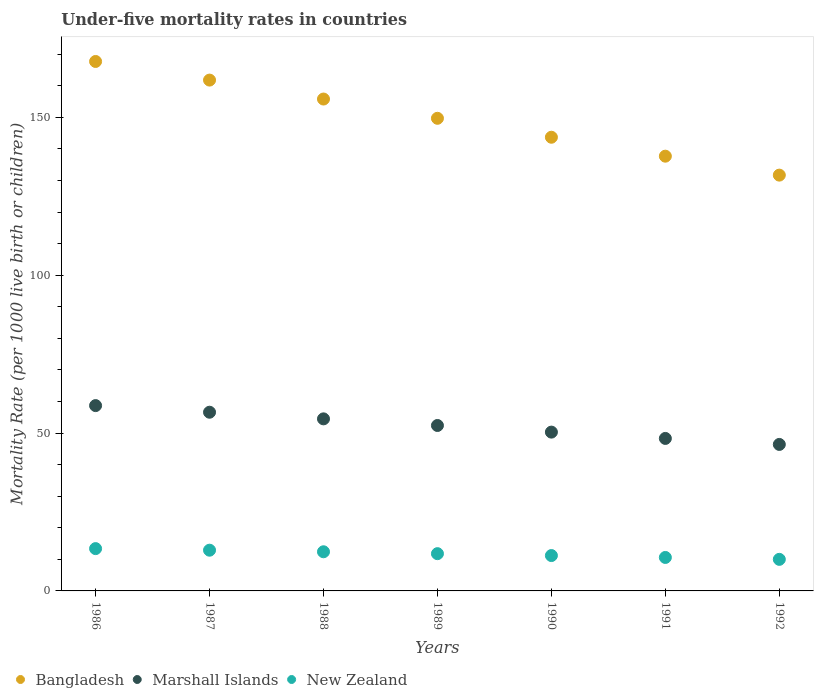How many different coloured dotlines are there?
Provide a succinct answer. 3. What is the under-five mortality rate in Bangladesh in 1992?
Provide a short and direct response. 131.7. Across all years, what is the maximum under-five mortality rate in New Zealand?
Provide a short and direct response. 13.4. Across all years, what is the minimum under-five mortality rate in Marshall Islands?
Offer a very short reply. 46.4. In which year was the under-five mortality rate in Marshall Islands maximum?
Keep it short and to the point. 1986. In which year was the under-five mortality rate in New Zealand minimum?
Your answer should be very brief. 1992. What is the total under-five mortality rate in Marshall Islands in the graph?
Provide a short and direct response. 367.2. What is the difference between the under-five mortality rate in Bangladesh in 1988 and the under-five mortality rate in Marshall Islands in 1987?
Your answer should be very brief. 99.2. What is the average under-five mortality rate in New Zealand per year?
Your answer should be very brief. 11.76. In the year 1992, what is the difference between the under-five mortality rate in New Zealand and under-five mortality rate in Marshall Islands?
Offer a very short reply. -36.4. What is the ratio of the under-five mortality rate in New Zealand in 1986 to that in 1992?
Provide a succinct answer. 1.34. Is the under-five mortality rate in Marshall Islands in 1986 less than that in 1989?
Your response must be concise. No. What is the difference between the highest and the second highest under-five mortality rate in Bangladesh?
Provide a short and direct response. 5.9. What is the difference between the highest and the lowest under-five mortality rate in New Zealand?
Your answer should be very brief. 3.4. Is it the case that in every year, the sum of the under-five mortality rate in Bangladesh and under-five mortality rate in Marshall Islands  is greater than the under-five mortality rate in New Zealand?
Keep it short and to the point. Yes. Is the under-five mortality rate in New Zealand strictly less than the under-five mortality rate in Bangladesh over the years?
Give a very brief answer. Yes. How many dotlines are there?
Provide a short and direct response. 3. What is the difference between two consecutive major ticks on the Y-axis?
Make the answer very short. 50. Does the graph contain any zero values?
Your response must be concise. No. Where does the legend appear in the graph?
Give a very brief answer. Bottom left. How are the legend labels stacked?
Ensure brevity in your answer.  Horizontal. What is the title of the graph?
Offer a terse response. Under-five mortality rates in countries. Does "Guam" appear as one of the legend labels in the graph?
Ensure brevity in your answer.  No. What is the label or title of the X-axis?
Make the answer very short. Years. What is the label or title of the Y-axis?
Make the answer very short. Mortality Rate (per 1000 live birth or children). What is the Mortality Rate (per 1000 live birth or children) in Bangladesh in 1986?
Offer a very short reply. 167.7. What is the Mortality Rate (per 1000 live birth or children) of Marshall Islands in 1986?
Keep it short and to the point. 58.7. What is the Mortality Rate (per 1000 live birth or children) in Bangladesh in 1987?
Provide a short and direct response. 161.8. What is the Mortality Rate (per 1000 live birth or children) in Marshall Islands in 1987?
Offer a terse response. 56.6. What is the Mortality Rate (per 1000 live birth or children) in Bangladesh in 1988?
Keep it short and to the point. 155.8. What is the Mortality Rate (per 1000 live birth or children) in Marshall Islands in 1988?
Offer a very short reply. 54.5. What is the Mortality Rate (per 1000 live birth or children) in New Zealand in 1988?
Make the answer very short. 12.4. What is the Mortality Rate (per 1000 live birth or children) of Bangladesh in 1989?
Your response must be concise. 149.7. What is the Mortality Rate (per 1000 live birth or children) in Marshall Islands in 1989?
Provide a succinct answer. 52.4. What is the Mortality Rate (per 1000 live birth or children) of New Zealand in 1989?
Your answer should be very brief. 11.8. What is the Mortality Rate (per 1000 live birth or children) of Bangladesh in 1990?
Give a very brief answer. 143.7. What is the Mortality Rate (per 1000 live birth or children) in Marshall Islands in 1990?
Provide a short and direct response. 50.3. What is the Mortality Rate (per 1000 live birth or children) in Bangladesh in 1991?
Your response must be concise. 137.7. What is the Mortality Rate (per 1000 live birth or children) in Marshall Islands in 1991?
Provide a short and direct response. 48.3. What is the Mortality Rate (per 1000 live birth or children) of Bangladesh in 1992?
Offer a very short reply. 131.7. What is the Mortality Rate (per 1000 live birth or children) in Marshall Islands in 1992?
Make the answer very short. 46.4. Across all years, what is the maximum Mortality Rate (per 1000 live birth or children) of Bangladesh?
Offer a terse response. 167.7. Across all years, what is the maximum Mortality Rate (per 1000 live birth or children) of Marshall Islands?
Your answer should be very brief. 58.7. Across all years, what is the maximum Mortality Rate (per 1000 live birth or children) of New Zealand?
Your answer should be compact. 13.4. Across all years, what is the minimum Mortality Rate (per 1000 live birth or children) of Bangladesh?
Make the answer very short. 131.7. Across all years, what is the minimum Mortality Rate (per 1000 live birth or children) of Marshall Islands?
Make the answer very short. 46.4. What is the total Mortality Rate (per 1000 live birth or children) in Bangladesh in the graph?
Offer a terse response. 1048.1. What is the total Mortality Rate (per 1000 live birth or children) in Marshall Islands in the graph?
Provide a short and direct response. 367.2. What is the total Mortality Rate (per 1000 live birth or children) in New Zealand in the graph?
Provide a succinct answer. 82.3. What is the difference between the Mortality Rate (per 1000 live birth or children) of Bangladesh in 1986 and that in 1987?
Your answer should be compact. 5.9. What is the difference between the Mortality Rate (per 1000 live birth or children) in New Zealand in 1986 and that in 1987?
Your answer should be very brief. 0.5. What is the difference between the Mortality Rate (per 1000 live birth or children) in Bangladesh in 1986 and that in 1988?
Give a very brief answer. 11.9. What is the difference between the Mortality Rate (per 1000 live birth or children) of New Zealand in 1986 and that in 1988?
Your answer should be compact. 1. What is the difference between the Mortality Rate (per 1000 live birth or children) of Marshall Islands in 1986 and that in 1990?
Give a very brief answer. 8.4. What is the difference between the Mortality Rate (per 1000 live birth or children) of New Zealand in 1986 and that in 1991?
Give a very brief answer. 2.8. What is the difference between the Mortality Rate (per 1000 live birth or children) in Marshall Islands in 1987 and that in 1988?
Your response must be concise. 2.1. What is the difference between the Mortality Rate (per 1000 live birth or children) of New Zealand in 1987 and that in 1988?
Keep it short and to the point. 0.5. What is the difference between the Mortality Rate (per 1000 live birth or children) in Marshall Islands in 1987 and that in 1989?
Provide a succinct answer. 4.2. What is the difference between the Mortality Rate (per 1000 live birth or children) of New Zealand in 1987 and that in 1990?
Give a very brief answer. 1.7. What is the difference between the Mortality Rate (per 1000 live birth or children) in Bangladesh in 1987 and that in 1991?
Provide a short and direct response. 24.1. What is the difference between the Mortality Rate (per 1000 live birth or children) of Marshall Islands in 1987 and that in 1991?
Make the answer very short. 8.3. What is the difference between the Mortality Rate (per 1000 live birth or children) of New Zealand in 1987 and that in 1991?
Provide a succinct answer. 2.3. What is the difference between the Mortality Rate (per 1000 live birth or children) of Bangladesh in 1987 and that in 1992?
Provide a succinct answer. 30.1. What is the difference between the Mortality Rate (per 1000 live birth or children) in Marshall Islands in 1987 and that in 1992?
Your response must be concise. 10.2. What is the difference between the Mortality Rate (per 1000 live birth or children) in Bangladesh in 1988 and that in 1989?
Your response must be concise. 6.1. What is the difference between the Mortality Rate (per 1000 live birth or children) in Bangladesh in 1988 and that in 1991?
Provide a succinct answer. 18.1. What is the difference between the Mortality Rate (per 1000 live birth or children) in Bangladesh in 1988 and that in 1992?
Keep it short and to the point. 24.1. What is the difference between the Mortality Rate (per 1000 live birth or children) of Marshall Islands in 1988 and that in 1992?
Your answer should be very brief. 8.1. What is the difference between the Mortality Rate (per 1000 live birth or children) of Bangladesh in 1989 and that in 1990?
Offer a very short reply. 6. What is the difference between the Mortality Rate (per 1000 live birth or children) of Marshall Islands in 1989 and that in 1990?
Your answer should be compact. 2.1. What is the difference between the Mortality Rate (per 1000 live birth or children) in Marshall Islands in 1989 and that in 1991?
Provide a short and direct response. 4.1. What is the difference between the Mortality Rate (per 1000 live birth or children) in New Zealand in 1989 and that in 1991?
Make the answer very short. 1.2. What is the difference between the Mortality Rate (per 1000 live birth or children) in Marshall Islands in 1989 and that in 1992?
Your response must be concise. 6. What is the difference between the Mortality Rate (per 1000 live birth or children) of New Zealand in 1990 and that in 1991?
Offer a terse response. 0.6. What is the difference between the Mortality Rate (per 1000 live birth or children) in New Zealand in 1991 and that in 1992?
Ensure brevity in your answer.  0.6. What is the difference between the Mortality Rate (per 1000 live birth or children) in Bangladesh in 1986 and the Mortality Rate (per 1000 live birth or children) in Marshall Islands in 1987?
Offer a very short reply. 111.1. What is the difference between the Mortality Rate (per 1000 live birth or children) in Bangladesh in 1986 and the Mortality Rate (per 1000 live birth or children) in New Zealand in 1987?
Provide a short and direct response. 154.8. What is the difference between the Mortality Rate (per 1000 live birth or children) in Marshall Islands in 1986 and the Mortality Rate (per 1000 live birth or children) in New Zealand in 1987?
Your answer should be compact. 45.8. What is the difference between the Mortality Rate (per 1000 live birth or children) in Bangladesh in 1986 and the Mortality Rate (per 1000 live birth or children) in Marshall Islands in 1988?
Offer a very short reply. 113.2. What is the difference between the Mortality Rate (per 1000 live birth or children) in Bangladesh in 1986 and the Mortality Rate (per 1000 live birth or children) in New Zealand in 1988?
Provide a succinct answer. 155.3. What is the difference between the Mortality Rate (per 1000 live birth or children) in Marshall Islands in 1986 and the Mortality Rate (per 1000 live birth or children) in New Zealand in 1988?
Your answer should be very brief. 46.3. What is the difference between the Mortality Rate (per 1000 live birth or children) of Bangladesh in 1986 and the Mortality Rate (per 1000 live birth or children) of Marshall Islands in 1989?
Your response must be concise. 115.3. What is the difference between the Mortality Rate (per 1000 live birth or children) in Bangladesh in 1986 and the Mortality Rate (per 1000 live birth or children) in New Zealand in 1989?
Provide a short and direct response. 155.9. What is the difference between the Mortality Rate (per 1000 live birth or children) in Marshall Islands in 1986 and the Mortality Rate (per 1000 live birth or children) in New Zealand in 1989?
Keep it short and to the point. 46.9. What is the difference between the Mortality Rate (per 1000 live birth or children) in Bangladesh in 1986 and the Mortality Rate (per 1000 live birth or children) in Marshall Islands in 1990?
Give a very brief answer. 117.4. What is the difference between the Mortality Rate (per 1000 live birth or children) in Bangladesh in 1986 and the Mortality Rate (per 1000 live birth or children) in New Zealand in 1990?
Provide a succinct answer. 156.5. What is the difference between the Mortality Rate (per 1000 live birth or children) in Marshall Islands in 1986 and the Mortality Rate (per 1000 live birth or children) in New Zealand in 1990?
Make the answer very short. 47.5. What is the difference between the Mortality Rate (per 1000 live birth or children) in Bangladesh in 1986 and the Mortality Rate (per 1000 live birth or children) in Marshall Islands in 1991?
Keep it short and to the point. 119.4. What is the difference between the Mortality Rate (per 1000 live birth or children) in Bangladesh in 1986 and the Mortality Rate (per 1000 live birth or children) in New Zealand in 1991?
Your answer should be compact. 157.1. What is the difference between the Mortality Rate (per 1000 live birth or children) in Marshall Islands in 1986 and the Mortality Rate (per 1000 live birth or children) in New Zealand in 1991?
Your response must be concise. 48.1. What is the difference between the Mortality Rate (per 1000 live birth or children) of Bangladesh in 1986 and the Mortality Rate (per 1000 live birth or children) of Marshall Islands in 1992?
Provide a short and direct response. 121.3. What is the difference between the Mortality Rate (per 1000 live birth or children) of Bangladesh in 1986 and the Mortality Rate (per 1000 live birth or children) of New Zealand in 1992?
Your answer should be very brief. 157.7. What is the difference between the Mortality Rate (per 1000 live birth or children) in Marshall Islands in 1986 and the Mortality Rate (per 1000 live birth or children) in New Zealand in 1992?
Provide a short and direct response. 48.7. What is the difference between the Mortality Rate (per 1000 live birth or children) in Bangladesh in 1987 and the Mortality Rate (per 1000 live birth or children) in Marshall Islands in 1988?
Give a very brief answer. 107.3. What is the difference between the Mortality Rate (per 1000 live birth or children) in Bangladesh in 1987 and the Mortality Rate (per 1000 live birth or children) in New Zealand in 1988?
Make the answer very short. 149.4. What is the difference between the Mortality Rate (per 1000 live birth or children) in Marshall Islands in 1987 and the Mortality Rate (per 1000 live birth or children) in New Zealand in 1988?
Offer a terse response. 44.2. What is the difference between the Mortality Rate (per 1000 live birth or children) in Bangladesh in 1987 and the Mortality Rate (per 1000 live birth or children) in Marshall Islands in 1989?
Ensure brevity in your answer.  109.4. What is the difference between the Mortality Rate (per 1000 live birth or children) of Bangladesh in 1987 and the Mortality Rate (per 1000 live birth or children) of New Zealand in 1989?
Your response must be concise. 150. What is the difference between the Mortality Rate (per 1000 live birth or children) in Marshall Islands in 1987 and the Mortality Rate (per 1000 live birth or children) in New Zealand in 1989?
Your answer should be compact. 44.8. What is the difference between the Mortality Rate (per 1000 live birth or children) of Bangladesh in 1987 and the Mortality Rate (per 1000 live birth or children) of Marshall Islands in 1990?
Provide a succinct answer. 111.5. What is the difference between the Mortality Rate (per 1000 live birth or children) in Bangladesh in 1987 and the Mortality Rate (per 1000 live birth or children) in New Zealand in 1990?
Make the answer very short. 150.6. What is the difference between the Mortality Rate (per 1000 live birth or children) of Marshall Islands in 1987 and the Mortality Rate (per 1000 live birth or children) of New Zealand in 1990?
Ensure brevity in your answer.  45.4. What is the difference between the Mortality Rate (per 1000 live birth or children) in Bangladesh in 1987 and the Mortality Rate (per 1000 live birth or children) in Marshall Islands in 1991?
Keep it short and to the point. 113.5. What is the difference between the Mortality Rate (per 1000 live birth or children) in Bangladesh in 1987 and the Mortality Rate (per 1000 live birth or children) in New Zealand in 1991?
Your response must be concise. 151.2. What is the difference between the Mortality Rate (per 1000 live birth or children) of Bangladesh in 1987 and the Mortality Rate (per 1000 live birth or children) of Marshall Islands in 1992?
Provide a succinct answer. 115.4. What is the difference between the Mortality Rate (per 1000 live birth or children) of Bangladesh in 1987 and the Mortality Rate (per 1000 live birth or children) of New Zealand in 1992?
Your answer should be very brief. 151.8. What is the difference between the Mortality Rate (per 1000 live birth or children) in Marshall Islands in 1987 and the Mortality Rate (per 1000 live birth or children) in New Zealand in 1992?
Offer a very short reply. 46.6. What is the difference between the Mortality Rate (per 1000 live birth or children) in Bangladesh in 1988 and the Mortality Rate (per 1000 live birth or children) in Marshall Islands in 1989?
Provide a short and direct response. 103.4. What is the difference between the Mortality Rate (per 1000 live birth or children) of Bangladesh in 1988 and the Mortality Rate (per 1000 live birth or children) of New Zealand in 1989?
Your answer should be compact. 144. What is the difference between the Mortality Rate (per 1000 live birth or children) in Marshall Islands in 1988 and the Mortality Rate (per 1000 live birth or children) in New Zealand in 1989?
Offer a terse response. 42.7. What is the difference between the Mortality Rate (per 1000 live birth or children) in Bangladesh in 1988 and the Mortality Rate (per 1000 live birth or children) in Marshall Islands in 1990?
Your answer should be very brief. 105.5. What is the difference between the Mortality Rate (per 1000 live birth or children) in Bangladesh in 1988 and the Mortality Rate (per 1000 live birth or children) in New Zealand in 1990?
Offer a terse response. 144.6. What is the difference between the Mortality Rate (per 1000 live birth or children) of Marshall Islands in 1988 and the Mortality Rate (per 1000 live birth or children) of New Zealand in 1990?
Give a very brief answer. 43.3. What is the difference between the Mortality Rate (per 1000 live birth or children) in Bangladesh in 1988 and the Mortality Rate (per 1000 live birth or children) in Marshall Islands in 1991?
Give a very brief answer. 107.5. What is the difference between the Mortality Rate (per 1000 live birth or children) of Bangladesh in 1988 and the Mortality Rate (per 1000 live birth or children) of New Zealand in 1991?
Provide a short and direct response. 145.2. What is the difference between the Mortality Rate (per 1000 live birth or children) of Marshall Islands in 1988 and the Mortality Rate (per 1000 live birth or children) of New Zealand in 1991?
Offer a terse response. 43.9. What is the difference between the Mortality Rate (per 1000 live birth or children) of Bangladesh in 1988 and the Mortality Rate (per 1000 live birth or children) of Marshall Islands in 1992?
Your answer should be very brief. 109.4. What is the difference between the Mortality Rate (per 1000 live birth or children) of Bangladesh in 1988 and the Mortality Rate (per 1000 live birth or children) of New Zealand in 1992?
Your response must be concise. 145.8. What is the difference between the Mortality Rate (per 1000 live birth or children) of Marshall Islands in 1988 and the Mortality Rate (per 1000 live birth or children) of New Zealand in 1992?
Your answer should be compact. 44.5. What is the difference between the Mortality Rate (per 1000 live birth or children) of Bangladesh in 1989 and the Mortality Rate (per 1000 live birth or children) of Marshall Islands in 1990?
Provide a succinct answer. 99.4. What is the difference between the Mortality Rate (per 1000 live birth or children) of Bangladesh in 1989 and the Mortality Rate (per 1000 live birth or children) of New Zealand in 1990?
Keep it short and to the point. 138.5. What is the difference between the Mortality Rate (per 1000 live birth or children) of Marshall Islands in 1989 and the Mortality Rate (per 1000 live birth or children) of New Zealand in 1990?
Keep it short and to the point. 41.2. What is the difference between the Mortality Rate (per 1000 live birth or children) of Bangladesh in 1989 and the Mortality Rate (per 1000 live birth or children) of Marshall Islands in 1991?
Provide a short and direct response. 101.4. What is the difference between the Mortality Rate (per 1000 live birth or children) in Bangladesh in 1989 and the Mortality Rate (per 1000 live birth or children) in New Zealand in 1991?
Offer a terse response. 139.1. What is the difference between the Mortality Rate (per 1000 live birth or children) of Marshall Islands in 1989 and the Mortality Rate (per 1000 live birth or children) of New Zealand in 1991?
Ensure brevity in your answer.  41.8. What is the difference between the Mortality Rate (per 1000 live birth or children) in Bangladesh in 1989 and the Mortality Rate (per 1000 live birth or children) in Marshall Islands in 1992?
Your answer should be very brief. 103.3. What is the difference between the Mortality Rate (per 1000 live birth or children) in Bangladesh in 1989 and the Mortality Rate (per 1000 live birth or children) in New Zealand in 1992?
Your answer should be very brief. 139.7. What is the difference between the Mortality Rate (per 1000 live birth or children) in Marshall Islands in 1989 and the Mortality Rate (per 1000 live birth or children) in New Zealand in 1992?
Keep it short and to the point. 42.4. What is the difference between the Mortality Rate (per 1000 live birth or children) in Bangladesh in 1990 and the Mortality Rate (per 1000 live birth or children) in Marshall Islands in 1991?
Your answer should be compact. 95.4. What is the difference between the Mortality Rate (per 1000 live birth or children) in Bangladesh in 1990 and the Mortality Rate (per 1000 live birth or children) in New Zealand in 1991?
Your answer should be compact. 133.1. What is the difference between the Mortality Rate (per 1000 live birth or children) in Marshall Islands in 1990 and the Mortality Rate (per 1000 live birth or children) in New Zealand in 1991?
Your answer should be compact. 39.7. What is the difference between the Mortality Rate (per 1000 live birth or children) of Bangladesh in 1990 and the Mortality Rate (per 1000 live birth or children) of Marshall Islands in 1992?
Ensure brevity in your answer.  97.3. What is the difference between the Mortality Rate (per 1000 live birth or children) of Bangladesh in 1990 and the Mortality Rate (per 1000 live birth or children) of New Zealand in 1992?
Offer a terse response. 133.7. What is the difference between the Mortality Rate (per 1000 live birth or children) of Marshall Islands in 1990 and the Mortality Rate (per 1000 live birth or children) of New Zealand in 1992?
Provide a short and direct response. 40.3. What is the difference between the Mortality Rate (per 1000 live birth or children) of Bangladesh in 1991 and the Mortality Rate (per 1000 live birth or children) of Marshall Islands in 1992?
Provide a short and direct response. 91.3. What is the difference between the Mortality Rate (per 1000 live birth or children) of Bangladesh in 1991 and the Mortality Rate (per 1000 live birth or children) of New Zealand in 1992?
Provide a succinct answer. 127.7. What is the difference between the Mortality Rate (per 1000 live birth or children) of Marshall Islands in 1991 and the Mortality Rate (per 1000 live birth or children) of New Zealand in 1992?
Give a very brief answer. 38.3. What is the average Mortality Rate (per 1000 live birth or children) in Bangladesh per year?
Make the answer very short. 149.73. What is the average Mortality Rate (per 1000 live birth or children) of Marshall Islands per year?
Your response must be concise. 52.46. What is the average Mortality Rate (per 1000 live birth or children) in New Zealand per year?
Your answer should be compact. 11.76. In the year 1986, what is the difference between the Mortality Rate (per 1000 live birth or children) in Bangladesh and Mortality Rate (per 1000 live birth or children) in Marshall Islands?
Keep it short and to the point. 109. In the year 1986, what is the difference between the Mortality Rate (per 1000 live birth or children) in Bangladesh and Mortality Rate (per 1000 live birth or children) in New Zealand?
Your response must be concise. 154.3. In the year 1986, what is the difference between the Mortality Rate (per 1000 live birth or children) of Marshall Islands and Mortality Rate (per 1000 live birth or children) of New Zealand?
Offer a very short reply. 45.3. In the year 1987, what is the difference between the Mortality Rate (per 1000 live birth or children) in Bangladesh and Mortality Rate (per 1000 live birth or children) in Marshall Islands?
Provide a short and direct response. 105.2. In the year 1987, what is the difference between the Mortality Rate (per 1000 live birth or children) in Bangladesh and Mortality Rate (per 1000 live birth or children) in New Zealand?
Your response must be concise. 148.9. In the year 1987, what is the difference between the Mortality Rate (per 1000 live birth or children) of Marshall Islands and Mortality Rate (per 1000 live birth or children) of New Zealand?
Ensure brevity in your answer.  43.7. In the year 1988, what is the difference between the Mortality Rate (per 1000 live birth or children) of Bangladesh and Mortality Rate (per 1000 live birth or children) of Marshall Islands?
Your response must be concise. 101.3. In the year 1988, what is the difference between the Mortality Rate (per 1000 live birth or children) of Bangladesh and Mortality Rate (per 1000 live birth or children) of New Zealand?
Keep it short and to the point. 143.4. In the year 1988, what is the difference between the Mortality Rate (per 1000 live birth or children) of Marshall Islands and Mortality Rate (per 1000 live birth or children) of New Zealand?
Make the answer very short. 42.1. In the year 1989, what is the difference between the Mortality Rate (per 1000 live birth or children) in Bangladesh and Mortality Rate (per 1000 live birth or children) in Marshall Islands?
Make the answer very short. 97.3. In the year 1989, what is the difference between the Mortality Rate (per 1000 live birth or children) in Bangladesh and Mortality Rate (per 1000 live birth or children) in New Zealand?
Your answer should be very brief. 137.9. In the year 1989, what is the difference between the Mortality Rate (per 1000 live birth or children) of Marshall Islands and Mortality Rate (per 1000 live birth or children) of New Zealand?
Provide a succinct answer. 40.6. In the year 1990, what is the difference between the Mortality Rate (per 1000 live birth or children) of Bangladesh and Mortality Rate (per 1000 live birth or children) of Marshall Islands?
Keep it short and to the point. 93.4. In the year 1990, what is the difference between the Mortality Rate (per 1000 live birth or children) in Bangladesh and Mortality Rate (per 1000 live birth or children) in New Zealand?
Your response must be concise. 132.5. In the year 1990, what is the difference between the Mortality Rate (per 1000 live birth or children) in Marshall Islands and Mortality Rate (per 1000 live birth or children) in New Zealand?
Give a very brief answer. 39.1. In the year 1991, what is the difference between the Mortality Rate (per 1000 live birth or children) in Bangladesh and Mortality Rate (per 1000 live birth or children) in Marshall Islands?
Offer a terse response. 89.4. In the year 1991, what is the difference between the Mortality Rate (per 1000 live birth or children) of Bangladesh and Mortality Rate (per 1000 live birth or children) of New Zealand?
Ensure brevity in your answer.  127.1. In the year 1991, what is the difference between the Mortality Rate (per 1000 live birth or children) in Marshall Islands and Mortality Rate (per 1000 live birth or children) in New Zealand?
Your response must be concise. 37.7. In the year 1992, what is the difference between the Mortality Rate (per 1000 live birth or children) of Bangladesh and Mortality Rate (per 1000 live birth or children) of Marshall Islands?
Provide a succinct answer. 85.3. In the year 1992, what is the difference between the Mortality Rate (per 1000 live birth or children) of Bangladesh and Mortality Rate (per 1000 live birth or children) of New Zealand?
Provide a succinct answer. 121.7. In the year 1992, what is the difference between the Mortality Rate (per 1000 live birth or children) of Marshall Islands and Mortality Rate (per 1000 live birth or children) of New Zealand?
Make the answer very short. 36.4. What is the ratio of the Mortality Rate (per 1000 live birth or children) of Bangladesh in 1986 to that in 1987?
Keep it short and to the point. 1.04. What is the ratio of the Mortality Rate (per 1000 live birth or children) of Marshall Islands in 1986 to that in 1987?
Offer a very short reply. 1.04. What is the ratio of the Mortality Rate (per 1000 live birth or children) in New Zealand in 1986 to that in 1987?
Offer a terse response. 1.04. What is the ratio of the Mortality Rate (per 1000 live birth or children) in Bangladesh in 1986 to that in 1988?
Your response must be concise. 1.08. What is the ratio of the Mortality Rate (per 1000 live birth or children) of Marshall Islands in 1986 to that in 1988?
Offer a very short reply. 1.08. What is the ratio of the Mortality Rate (per 1000 live birth or children) in New Zealand in 1986 to that in 1988?
Offer a very short reply. 1.08. What is the ratio of the Mortality Rate (per 1000 live birth or children) of Bangladesh in 1986 to that in 1989?
Your answer should be compact. 1.12. What is the ratio of the Mortality Rate (per 1000 live birth or children) of Marshall Islands in 1986 to that in 1989?
Provide a succinct answer. 1.12. What is the ratio of the Mortality Rate (per 1000 live birth or children) of New Zealand in 1986 to that in 1989?
Your answer should be very brief. 1.14. What is the ratio of the Mortality Rate (per 1000 live birth or children) of Bangladesh in 1986 to that in 1990?
Provide a short and direct response. 1.17. What is the ratio of the Mortality Rate (per 1000 live birth or children) of Marshall Islands in 1986 to that in 1990?
Ensure brevity in your answer.  1.17. What is the ratio of the Mortality Rate (per 1000 live birth or children) in New Zealand in 1986 to that in 1990?
Offer a terse response. 1.2. What is the ratio of the Mortality Rate (per 1000 live birth or children) in Bangladesh in 1986 to that in 1991?
Give a very brief answer. 1.22. What is the ratio of the Mortality Rate (per 1000 live birth or children) in Marshall Islands in 1986 to that in 1991?
Your answer should be compact. 1.22. What is the ratio of the Mortality Rate (per 1000 live birth or children) in New Zealand in 1986 to that in 1991?
Provide a short and direct response. 1.26. What is the ratio of the Mortality Rate (per 1000 live birth or children) of Bangladesh in 1986 to that in 1992?
Give a very brief answer. 1.27. What is the ratio of the Mortality Rate (per 1000 live birth or children) of Marshall Islands in 1986 to that in 1992?
Offer a very short reply. 1.27. What is the ratio of the Mortality Rate (per 1000 live birth or children) of New Zealand in 1986 to that in 1992?
Your answer should be compact. 1.34. What is the ratio of the Mortality Rate (per 1000 live birth or children) in Bangladesh in 1987 to that in 1988?
Keep it short and to the point. 1.04. What is the ratio of the Mortality Rate (per 1000 live birth or children) of New Zealand in 1987 to that in 1988?
Your answer should be compact. 1.04. What is the ratio of the Mortality Rate (per 1000 live birth or children) of Bangladesh in 1987 to that in 1989?
Provide a short and direct response. 1.08. What is the ratio of the Mortality Rate (per 1000 live birth or children) of Marshall Islands in 1987 to that in 1989?
Provide a succinct answer. 1.08. What is the ratio of the Mortality Rate (per 1000 live birth or children) in New Zealand in 1987 to that in 1989?
Make the answer very short. 1.09. What is the ratio of the Mortality Rate (per 1000 live birth or children) of Bangladesh in 1987 to that in 1990?
Keep it short and to the point. 1.13. What is the ratio of the Mortality Rate (per 1000 live birth or children) of Marshall Islands in 1987 to that in 1990?
Provide a succinct answer. 1.13. What is the ratio of the Mortality Rate (per 1000 live birth or children) in New Zealand in 1987 to that in 1990?
Keep it short and to the point. 1.15. What is the ratio of the Mortality Rate (per 1000 live birth or children) in Bangladesh in 1987 to that in 1991?
Your answer should be compact. 1.18. What is the ratio of the Mortality Rate (per 1000 live birth or children) of Marshall Islands in 1987 to that in 1991?
Ensure brevity in your answer.  1.17. What is the ratio of the Mortality Rate (per 1000 live birth or children) of New Zealand in 1987 to that in 1991?
Keep it short and to the point. 1.22. What is the ratio of the Mortality Rate (per 1000 live birth or children) of Bangladesh in 1987 to that in 1992?
Your answer should be compact. 1.23. What is the ratio of the Mortality Rate (per 1000 live birth or children) in Marshall Islands in 1987 to that in 1992?
Offer a very short reply. 1.22. What is the ratio of the Mortality Rate (per 1000 live birth or children) of New Zealand in 1987 to that in 1992?
Offer a very short reply. 1.29. What is the ratio of the Mortality Rate (per 1000 live birth or children) of Bangladesh in 1988 to that in 1989?
Give a very brief answer. 1.04. What is the ratio of the Mortality Rate (per 1000 live birth or children) in Marshall Islands in 1988 to that in 1989?
Give a very brief answer. 1.04. What is the ratio of the Mortality Rate (per 1000 live birth or children) in New Zealand in 1988 to that in 1989?
Offer a terse response. 1.05. What is the ratio of the Mortality Rate (per 1000 live birth or children) in Bangladesh in 1988 to that in 1990?
Provide a short and direct response. 1.08. What is the ratio of the Mortality Rate (per 1000 live birth or children) in Marshall Islands in 1988 to that in 1990?
Your answer should be compact. 1.08. What is the ratio of the Mortality Rate (per 1000 live birth or children) in New Zealand in 1988 to that in 1990?
Keep it short and to the point. 1.11. What is the ratio of the Mortality Rate (per 1000 live birth or children) in Bangladesh in 1988 to that in 1991?
Your response must be concise. 1.13. What is the ratio of the Mortality Rate (per 1000 live birth or children) in Marshall Islands in 1988 to that in 1991?
Provide a succinct answer. 1.13. What is the ratio of the Mortality Rate (per 1000 live birth or children) of New Zealand in 1988 to that in 1991?
Make the answer very short. 1.17. What is the ratio of the Mortality Rate (per 1000 live birth or children) in Bangladesh in 1988 to that in 1992?
Your response must be concise. 1.18. What is the ratio of the Mortality Rate (per 1000 live birth or children) in Marshall Islands in 1988 to that in 1992?
Your response must be concise. 1.17. What is the ratio of the Mortality Rate (per 1000 live birth or children) in New Zealand in 1988 to that in 1992?
Ensure brevity in your answer.  1.24. What is the ratio of the Mortality Rate (per 1000 live birth or children) of Bangladesh in 1989 to that in 1990?
Your response must be concise. 1.04. What is the ratio of the Mortality Rate (per 1000 live birth or children) of Marshall Islands in 1989 to that in 1990?
Make the answer very short. 1.04. What is the ratio of the Mortality Rate (per 1000 live birth or children) of New Zealand in 1989 to that in 1990?
Your answer should be very brief. 1.05. What is the ratio of the Mortality Rate (per 1000 live birth or children) in Bangladesh in 1989 to that in 1991?
Your response must be concise. 1.09. What is the ratio of the Mortality Rate (per 1000 live birth or children) in Marshall Islands in 1989 to that in 1991?
Make the answer very short. 1.08. What is the ratio of the Mortality Rate (per 1000 live birth or children) of New Zealand in 1989 to that in 1991?
Your response must be concise. 1.11. What is the ratio of the Mortality Rate (per 1000 live birth or children) in Bangladesh in 1989 to that in 1992?
Make the answer very short. 1.14. What is the ratio of the Mortality Rate (per 1000 live birth or children) in Marshall Islands in 1989 to that in 1992?
Offer a terse response. 1.13. What is the ratio of the Mortality Rate (per 1000 live birth or children) in New Zealand in 1989 to that in 1992?
Give a very brief answer. 1.18. What is the ratio of the Mortality Rate (per 1000 live birth or children) of Bangladesh in 1990 to that in 1991?
Ensure brevity in your answer.  1.04. What is the ratio of the Mortality Rate (per 1000 live birth or children) in Marshall Islands in 1990 to that in 1991?
Make the answer very short. 1.04. What is the ratio of the Mortality Rate (per 1000 live birth or children) in New Zealand in 1990 to that in 1991?
Your answer should be compact. 1.06. What is the ratio of the Mortality Rate (per 1000 live birth or children) of Bangladesh in 1990 to that in 1992?
Offer a very short reply. 1.09. What is the ratio of the Mortality Rate (per 1000 live birth or children) in Marshall Islands in 1990 to that in 1992?
Make the answer very short. 1.08. What is the ratio of the Mortality Rate (per 1000 live birth or children) in New Zealand in 1990 to that in 1992?
Offer a very short reply. 1.12. What is the ratio of the Mortality Rate (per 1000 live birth or children) of Bangladesh in 1991 to that in 1992?
Your answer should be compact. 1.05. What is the ratio of the Mortality Rate (per 1000 live birth or children) in Marshall Islands in 1991 to that in 1992?
Offer a very short reply. 1.04. What is the ratio of the Mortality Rate (per 1000 live birth or children) in New Zealand in 1991 to that in 1992?
Keep it short and to the point. 1.06. What is the difference between the highest and the second highest Mortality Rate (per 1000 live birth or children) of Bangladesh?
Give a very brief answer. 5.9. What is the difference between the highest and the second highest Mortality Rate (per 1000 live birth or children) of Marshall Islands?
Give a very brief answer. 2.1. What is the difference between the highest and the second highest Mortality Rate (per 1000 live birth or children) in New Zealand?
Your response must be concise. 0.5. 